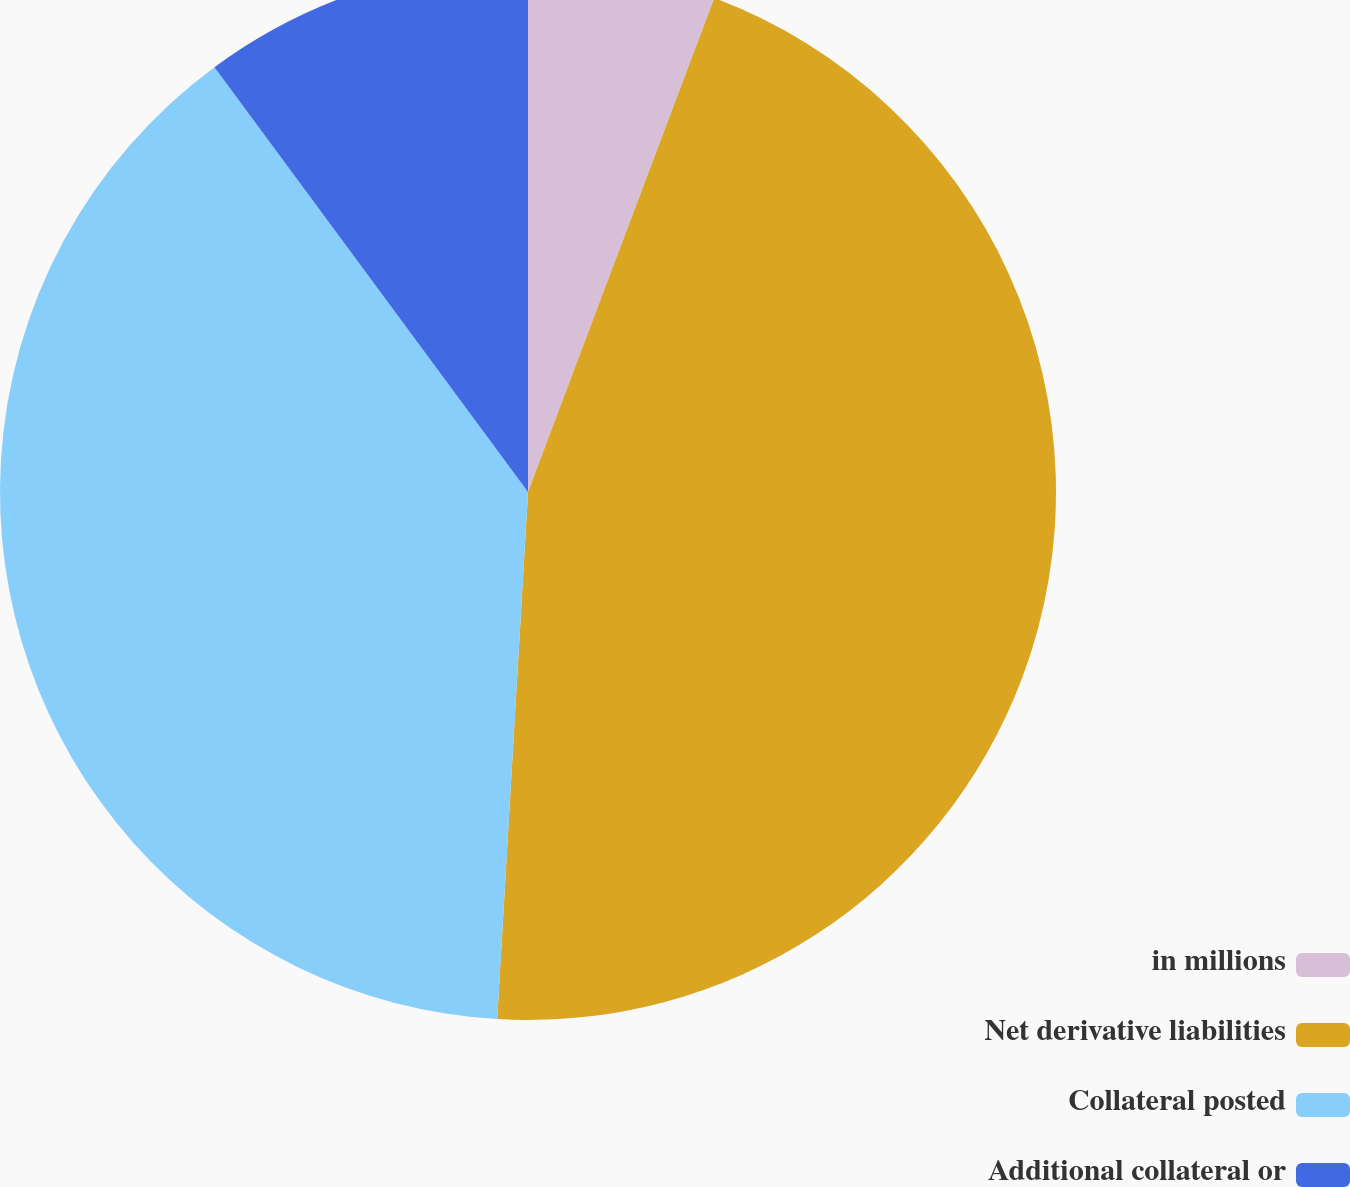Convert chart. <chart><loc_0><loc_0><loc_500><loc_500><pie_chart><fcel>in millions<fcel>Net derivative liabilities<fcel>Collateral posted<fcel>Additional collateral or<nl><fcel>5.74%<fcel>45.19%<fcel>38.95%<fcel>10.12%<nl></chart> 